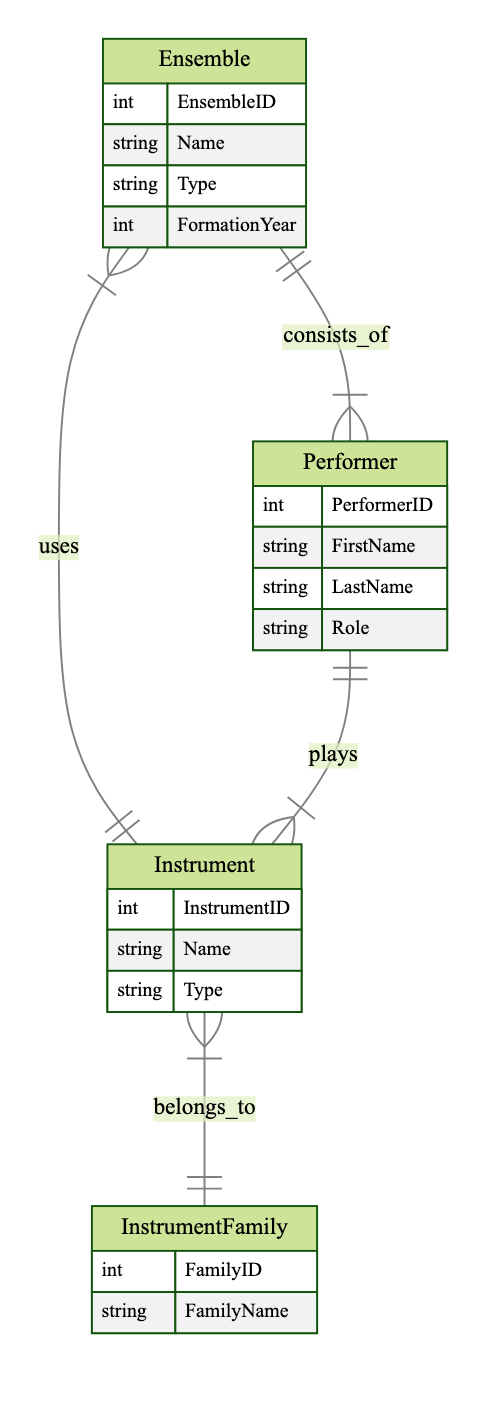What is the unique identifier for each Ensemble? Each Ensemble is identified by a unique attribute called EnsembleID, which is specified in the attributes section of the Ensemble entity.
Answer: EnsembleID How many Performer roles can an Ensemble consist of? The relationship named "consists_of" indicates that an Ensemble can have one-to-many relations with Performer, meaning each Ensemble can consist of multiple Performers, but each Performer relates to one Ensemble only.
Answer: many What type of relationship exists between Ensemble and Instrument? The relationship between Ensemble and Instrument is defined as "uses", indicating that an Ensemble can use multiple instruments and an Instrument can belong to multiple Ensembles.
Answer: many-to-many What is the maximum number of Instrument Families an Instrument can belong to? An Instrument can belong to only one Instrument Family, as indicated by the relationship "belongs_to", which is many-to-one.
Answer: one How many attributes does the Performer entity have? The Performer entity has four specified attributes: PerformerID, FirstName, LastName, and Role.
Answer: four Can a Performer play multiple Instruments? Yes, the relationship "plays" shows that each Performer can play many Instruments, indicating a one-to-many relationship from Performer to Instrument.
Answer: yes How many types of Instruments are listed in this diagram? The diagram specifies one type of instrument using an attribute for each Instrument entity. However, the exact number isn't provided in the diagram structure.
Answer: many What is one attribute of the InstrumentFamily entity? The InstrumentFamily entity has the attribute FamilyName listed among its attributes.
Answer: FamilyName What is the role of a Performer in an Ensemble? The role of a Performer is identified by the "Role" attribute in the Performer entity, which indicates the specific function or position of a Performer within an Ensemble.
Answer: Role 